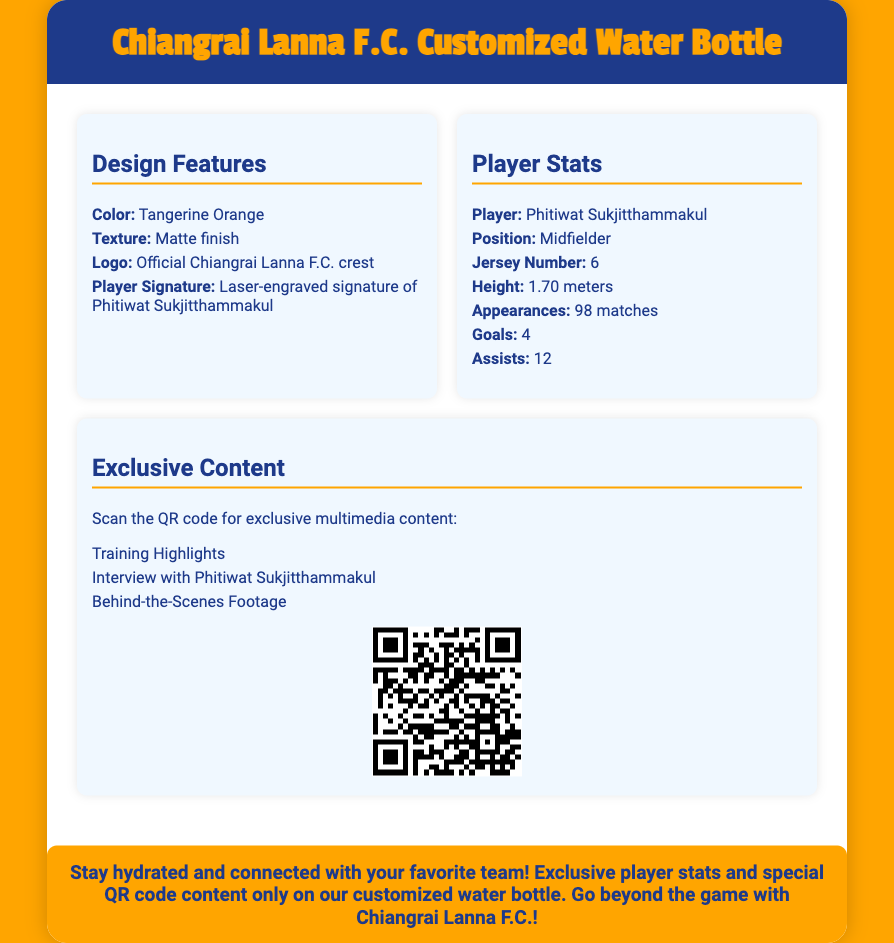What is the color of the water bottle? The color of the water bottle is specified in the design features section.
Answer: Tangerine Orange Who is the player featured on the water bottle? The player's name is mentioned under the player stats section.
Answer: Phitiwat Sukjitthammakul What position does Phitiwat Sukjitthammakul play? The player's position is listed in the player stats section.
Answer: Midfielder How many assists has Phitiwat Sukjitthammakul made? The number of assists is provided in the player stats section.
Answer: 12 What can be accessed by scanning the QR code? The exclusive content that can be accessed is detailed under the exclusive content section.
Answer: Training Highlights What is the jersey number of Phitiwat Sukjitthammakul? The jersey number is listed in the player stats section.
Answer: 6 What is the promotional message on the packaging? The promotional message is found at the end of the document.
Answer: Stay hydrated and connected with your favorite team! What is the height of Phitiwat Sukjitthammakul? The height is specified in the player stats section.
Answer: 1.70 meters How many matches has Phitiwat Sukjitthammakul appeared in? The total number of appearances is provided in the player stats section.
Answer: 98 matches 